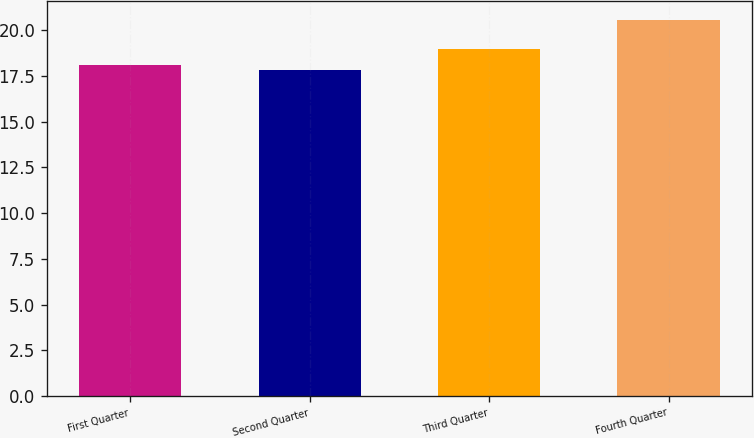<chart> <loc_0><loc_0><loc_500><loc_500><bar_chart><fcel>First Quarter<fcel>Second Quarter<fcel>Third Quarter<fcel>Fourth Quarter<nl><fcel>18.08<fcel>17.8<fcel>18.96<fcel>20.56<nl></chart> 